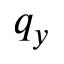Convert formula to latex. <formula><loc_0><loc_0><loc_500><loc_500>q _ { y }</formula> 